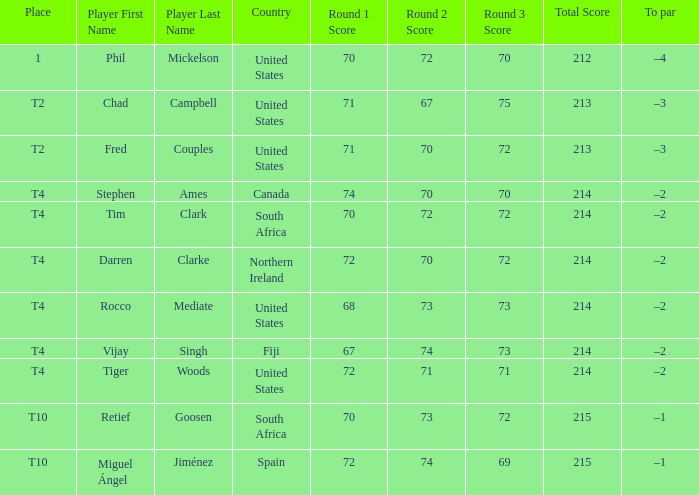What par does rocco mediate have? –2. 